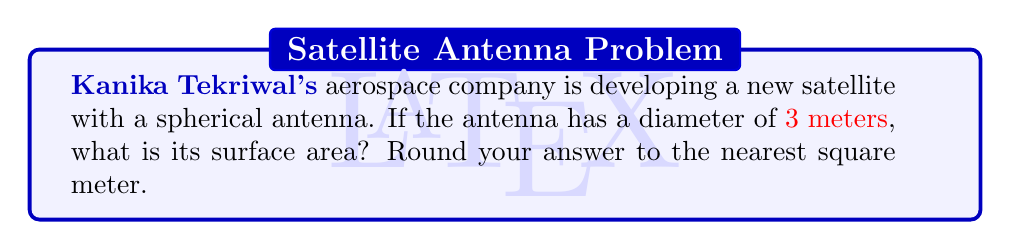Can you solve this math problem? Let's approach this step-by-step:

1) The formula for the surface area of a sphere is:

   $$A = 4\pi r^2$$

   where $A$ is the surface area and $r$ is the radius.

2) We're given the diameter, which is 3 meters. The radius is half of the diameter:

   $$r = \frac{3}{2} = 1.5 \text{ meters}$$

3) Now, let's substitute this into our formula:

   $$A = 4\pi (1.5)^2$$

4) Let's calculate:

   $$A = 4\pi (2.25)$$
   $$A = 9\pi$$

5) Using $\pi \approx 3.14159$:

   $$A \approx 9 * 3.14159 = 28.27431 \text{ square meters}$$

6) Rounding to the nearest square meter:

   $$A \approx 28 \text{ square meters}$$
Answer: $28 \text{ m}^2$ 